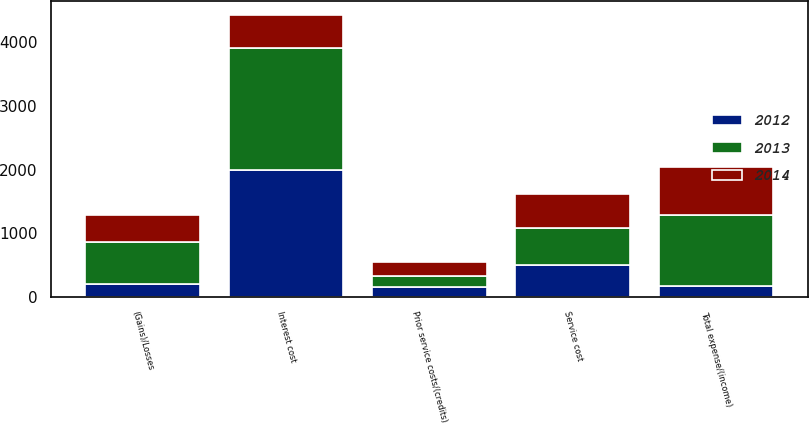Convert chart to OTSL. <chart><loc_0><loc_0><loc_500><loc_500><stacked_bar_chart><ecel><fcel>Service cost<fcel>Interest cost<fcel>Prior service costs/(credits)<fcel>(Gains)/Losses<fcel>Total expense/(income)<nl><fcel>2012<fcel>507<fcel>1992<fcel>155<fcel>207<fcel>167<nl><fcel>2013<fcel>581<fcel>1914<fcel>174<fcel>655<fcel>1112<nl><fcel>2014<fcel>521<fcel>514<fcel>220<fcel>425<fcel>758<nl></chart> 